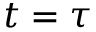Convert formula to latex. <formula><loc_0><loc_0><loc_500><loc_500>t = \tau</formula> 